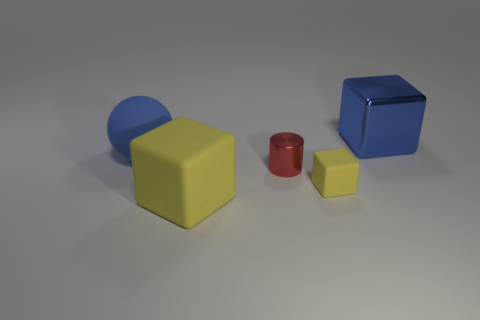Are the large block that is to the right of the big yellow cube and the big thing in front of the large matte sphere made of the same material?
Keep it short and to the point. No. What size is the yellow block to the right of the small cylinder?
Your answer should be very brief. Small. The blue matte thing has what size?
Your answer should be compact. Large. How big is the blue thing that is to the right of the large matte object on the left side of the large thing that is in front of the big blue rubber object?
Give a very brief answer. Large. Is there a large blue thing that has the same material as the small block?
Provide a short and direct response. Yes. The small yellow matte thing is what shape?
Give a very brief answer. Cube. There is a ball that is the same material as the big yellow block; what color is it?
Make the answer very short. Blue. What number of gray objects are rubber objects or shiny blocks?
Keep it short and to the point. 0. Is the number of yellow blocks greater than the number of metal cubes?
Offer a terse response. Yes. What number of things are either large matte things that are right of the big matte ball or big blocks left of the big blue metal cube?
Your answer should be very brief. 1. 